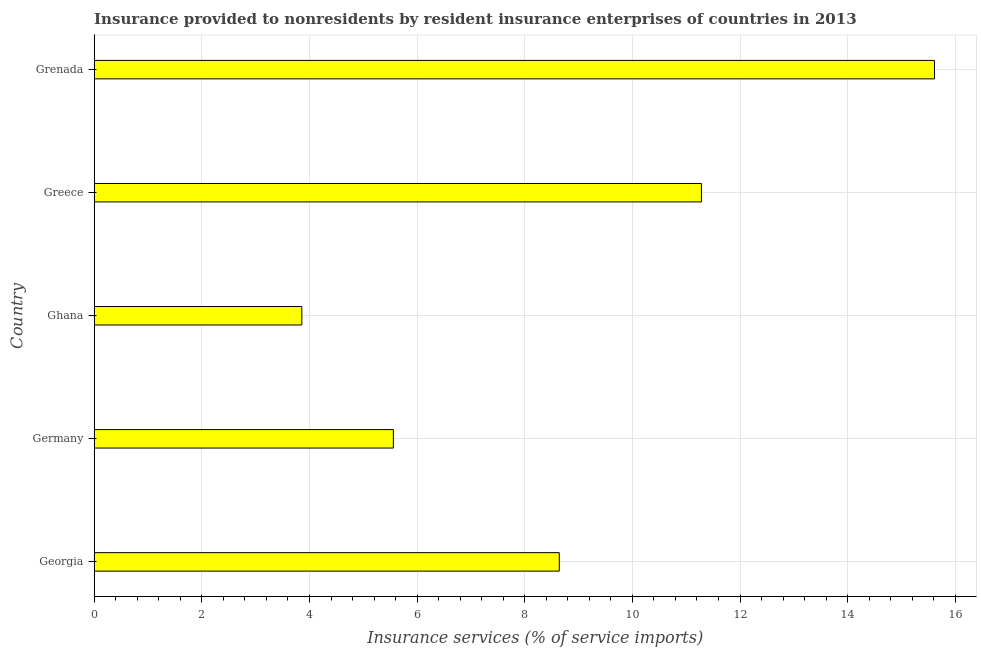Does the graph contain any zero values?
Ensure brevity in your answer.  No. Does the graph contain grids?
Keep it short and to the point. Yes. What is the title of the graph?
Make the answer very short. Insurance provided to nonresidents by resident insurance enterprises of countries in 2013. What is the label or title of the X-axis?
Provide a succinct answer. Insurance services (% of service imports). What is the insurance and financial services in Grenada?
Offer a very short reply. 15.61. Across all countries, what is the maximum insurance and financial services?
Offer a terse response. 15.61. Across all countries, what is the minimum insurance and financial services?
Keep it short and to the point. 3.86. In which country was the insurance and financial services maximum?
Your response must be concise. Grenada. In which country was the insurance and financial services minimum?
Provide a succinct answer. Ghana. What is the sum of the insurance and financial services?
Your response must be concise. 44.95. What is the difference between the insurance and financial services in Georgia and Germany?
Your answer should be compact. 3.08. What is the average insurance and financial services per country?
Ensure brevity in your answer.  8.99. What is the median insurance and financial services?
Keep it short and to the point. 8.64. What is the ratio of the insurance and financial services in Germany to that in Greece?
Provide a short and direct response. 0.49. Is the insurance and financial services in Georgia less than that in Germany?
Make the answer very short. No. What is the difference between the highest and the second highest insurance and financial services?
Your answer should be very brief. 4.33. What is the difference between the highest and the lowest insurance and financial services?
Ensure brevity in your answer.  11.76. In how many countries, is the insurance and financial services greater than the average insurance and financial services taken over all countries?
Your answer should be very brief. 2. How many bars are there?
Offer a terse response. 5. What is the Insurance services (% of service imports) of Georgia?
Your response must be concise. 8.64. What is the Insurance services (% of service imports) in Germany?
Offer a terse response. 5.56. What is the Insurance services (% of service imports) in Ghana?
Give a very brief answer. 3.86. What is the Insurance services (% of service imports) of Greece?
Ensure brevity in your answer.  11.28. What is the Insurance services (% of service imports) in Grenada?
Your answer should be compact. 15.61. What is the difference between the Insurance services (% of service imports) in Georgia and Germany?
Offer a very short reply. 3.08. What is the difference between the Insurance services (% of service imports) in Georgia and Ghana?
Offer a very short reply. 4.78. What is the difference between the Insurance services (% of service imports) in Georgia and Greece?
Your answer should be very brief. -2.64. What is the difference between the Insurance services (% of service imports) in Georgia and Grenada?
Ensure brevity in your answer.  -6.97. What is the difference between the Insurance services (% of service imports) in Germany and Ghana?
Your answer should be compact. 1.7. What is the difference between the Insurance services (% of service imports) in Germany and Greece?
Give a very brief answer. -5.72. What is the difference between the Insurance services (% of service imports) in Germany and Grenada?
Ensure brevity in your answer.  -10.05. What is the difference between the Insurance services (% of service imports) in Ghana and Greece?
Make the answer very short. -7.43. What is the difference between the Insurance services (% of service imports) in Ghana and Grenada?
Provide a short and direct response. -11.76. What is the difference between the Insurance services (% of service imports) in Greece and Grenada?
Give a very brief answer. -4.33. What is the ratio of the Insurance services (% of service imports) in Georgia to that in Germany?
Offer a very short reply. 1.55. What is the ratio of the Insurance services (% of service imports) in Georgia to that in Ghana?
Your answer should be compact. 2.24. What is the ratio of the Insurance services (% of service imports) in Georgia to that in Greece?
Provide a succinct answer. 0.77. What is the ratio of the Insurance services (% of service imports) in Georgia to that in Grenada?
Your answer should be very brief. 0.55. What is the ratio of the Insurance services (% of service imports) in Germany to that in Ghana?
Give a very brief answer. 1.44. What is the ratio of the Insurance services (% of service imports) in Germany to that in Greece?
Keep it short and to the point. 0.49. What is the ratio of the Insurance services (% of service imports) in Germany to that in Grenada?
Make the answer very short. 0.36. What is the ratio of the Insurance services (% of service imports) in Ghana to that in Greece?
Make the answer very short. 0.34. What is the ratio of the Insurance services (% of service imports) in Ghana to that in Grenada?
Your response must be concise. 0.25. What is the ratio of the Insurance services (% of service imports) in Greece to that in Grenada?
Offer a very short reply. 0.72. 